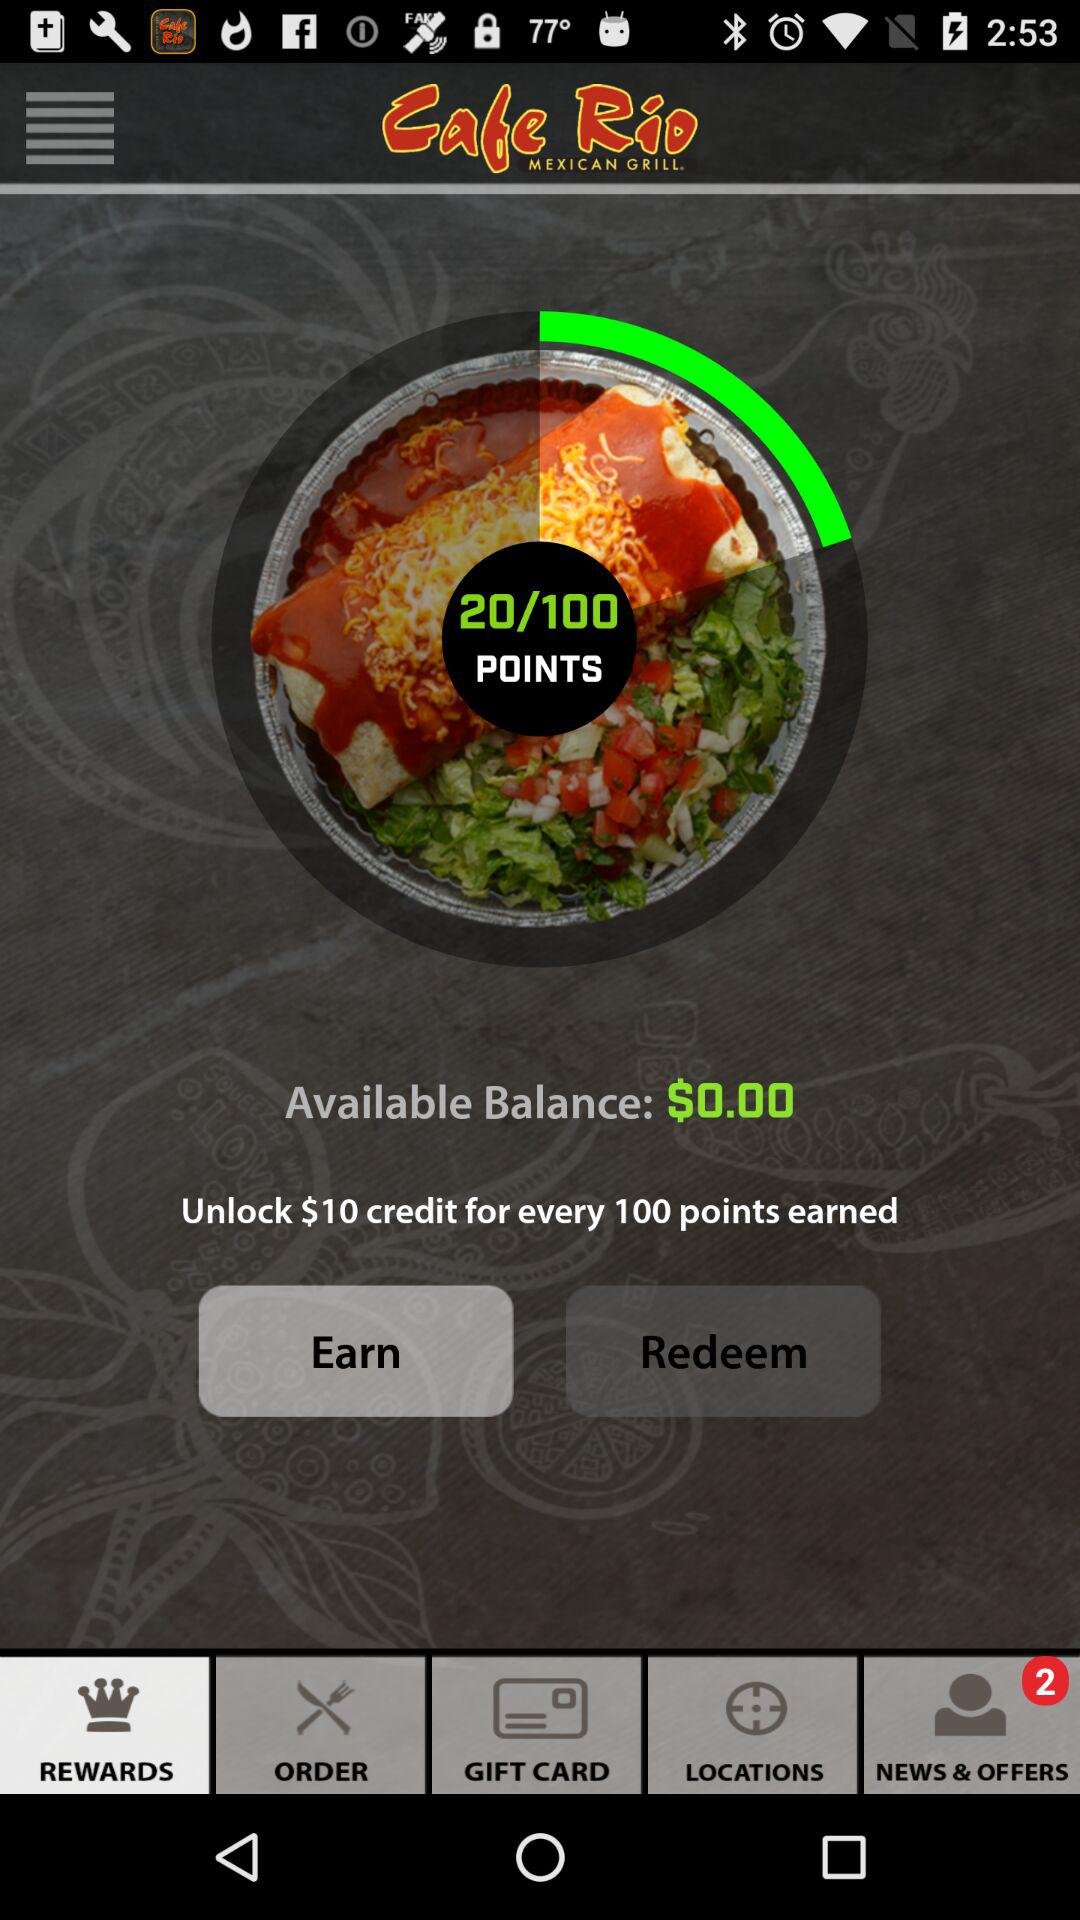How do I earn points with this rewards program? Points are typically earned by making purchases at the associated establishment. Every dollar spent can contribute a certain number of points to your rewards account. You can earn more points by participating in special promotional events or offers that may be periodically available. 